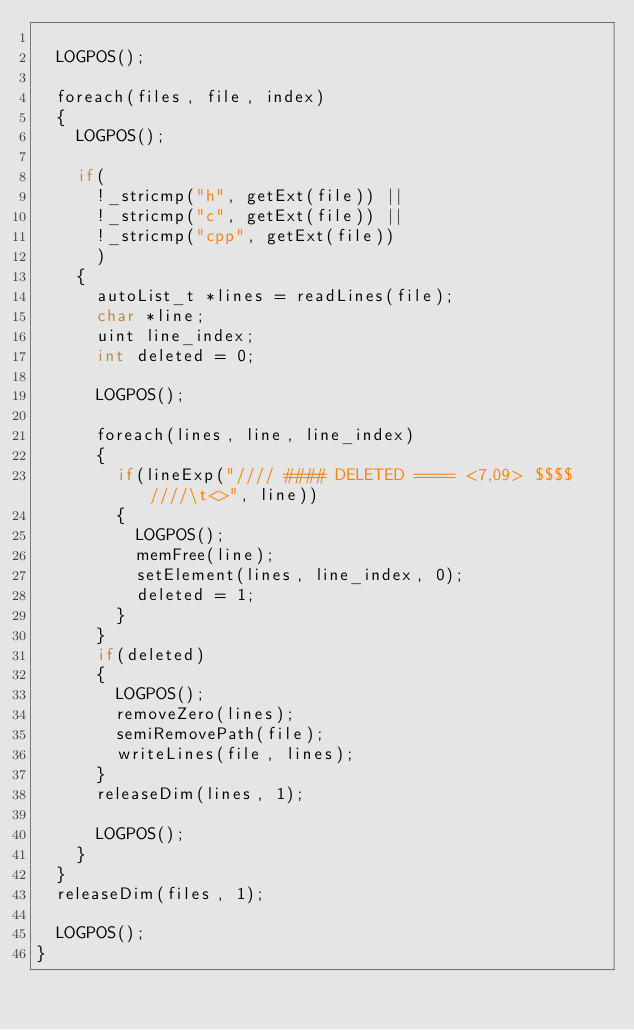<code> <loc_0><loc_0><loc_500><loc_500><_C_>
	LOGPOS();

	foreach(files, file, index)
	{
		LOGPOS();

		if(
			!_stricmp("h", getExt(file)) ||
			!_stricmp("c", getExt(file)) ||
			!_stricmp("cpp", getExt(file))
			)
		{
			autoList_t *lines = readLines(file);
			char *line;
			uint line_index;
			int deleted = 0;

			LOGPOS();

			foreach(lines, line, line_index)
			{
				if(lineExp("//// #### DELETED ==== <7,09> $$$$ ////\t<>", line))
				{
					LOGPOS();
					memFree(line);
					setElement(lines, line_index, 0);
					deleted = 1;
				}
			}
			if(deleted)
			{
				LOGPOS();
				removeZero(lines);
				semiRemovePath(file);
				writeLines(file, lines);
			}
			releaseDim(lines, 1);

			LOGPOS();
		}
	}
	releaseDim(files, 1);

	LOGPOS();
}
</code> 